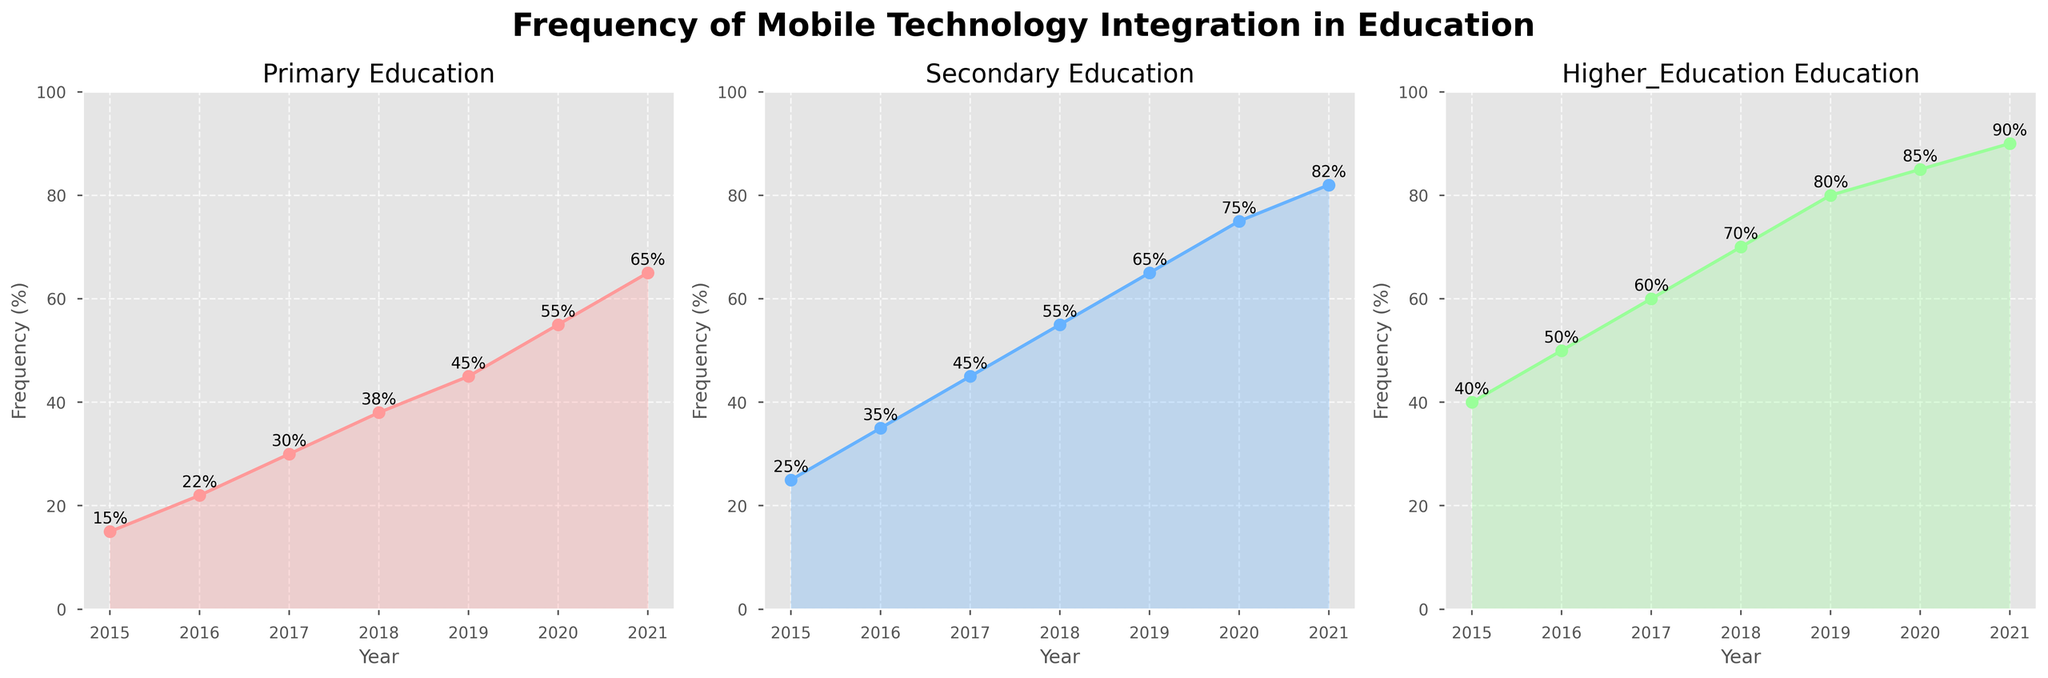What's the trend of mobile technology integration in primary education over the years? To determine the trend, observe the line graph for primary education. The frequencies start at 15% in 2015 and increase each year until they reach 65% in 2021. This indicates a clear upward trend in the integration of mobile technology in primary education.
Answer: Upward Which educational level had the highest percentage of mobile technology integration in 2018? Compare the percentages for all three educational levels in 2018. Primary education was at 38%, secondary education at 55%, and higher education at 70%. Higher education had the highest percentage.
Answer: Higher education During which year was the increase in integration percentage the highest for secondary education? Calculate the year-to-year changes in percentage for secondary education: 2015-16 (10%), 2016-17 (10%), 2017-18 (10%), 2018-19 (10%), 2019-20 (10%), 2020-21 (7%). The highest increase was consistently 10%, occurring each year from 2015 to 2020.
Answer: 2016-2017 What is the average integration percentage for higher education from 2015 to 2021? Calculate the sum of percentages for higher education and divide by the number of years: (40+50+60+70+80+85+90)/7 = 475/7 ≈ 67.86%.
Answer: 67.86% Which educational level shows the most rapid growth in mobile technology integration from 2015 to 2021? Analyze the growth in integration percentage from 2015 to 2021 for each educational level. Primary (50 percentage points), Secondary (57 percentage points), Higher Education (50 percentage points). Secondary Education shows the most rapid growth.
Answer: Secondary How does the integration percentage in higher education in 2021 compare to primary education in the same year? Compare the 2021 integration percentages. In 2021, primary education is at 65% and higher education is at 90%. Higher education has a higher integration percentage by 25%.
Answer: Higher by 25% Is there any year where the frequency percentage of mobile technology integration is the same across all educational levels? Observe the lines for all three educational levels across the years. In none of the years do the percentages equal each other.
Answer: No What is the difference in mobile technology integration between secondary and higher education in 2019? Compare 2019 percentages: Secondary (65%) and Higher Education (80%). Calculate the difference: 80 - 65 = 15%.
Answer: 15% 